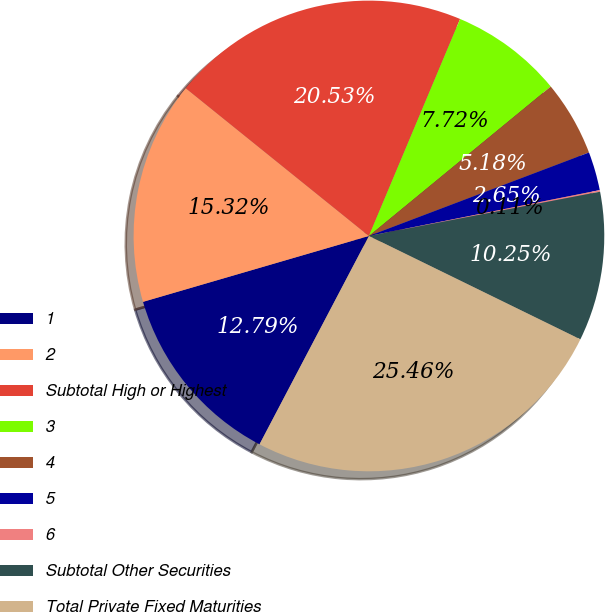Convert chart. <chart><loc_0><loc_0><loc_500><loc_500><pie_chart><fcel>1<fcel>2<fcel>Subtotal High or Highest<fcel>3<fcel>4<fcel>5<fcel>6<fcel>Subtotal Other Securities<fcel>Total Private Fixed Maturities<nl><fcel>12.79%<fcel>15.32%<fcel>20.53%<fcel>7.72%<fcel>5.18%<fcel>2.65%<fcel>0.11%<fcel>10.25%<fcel>25.46%<nl></chart> 